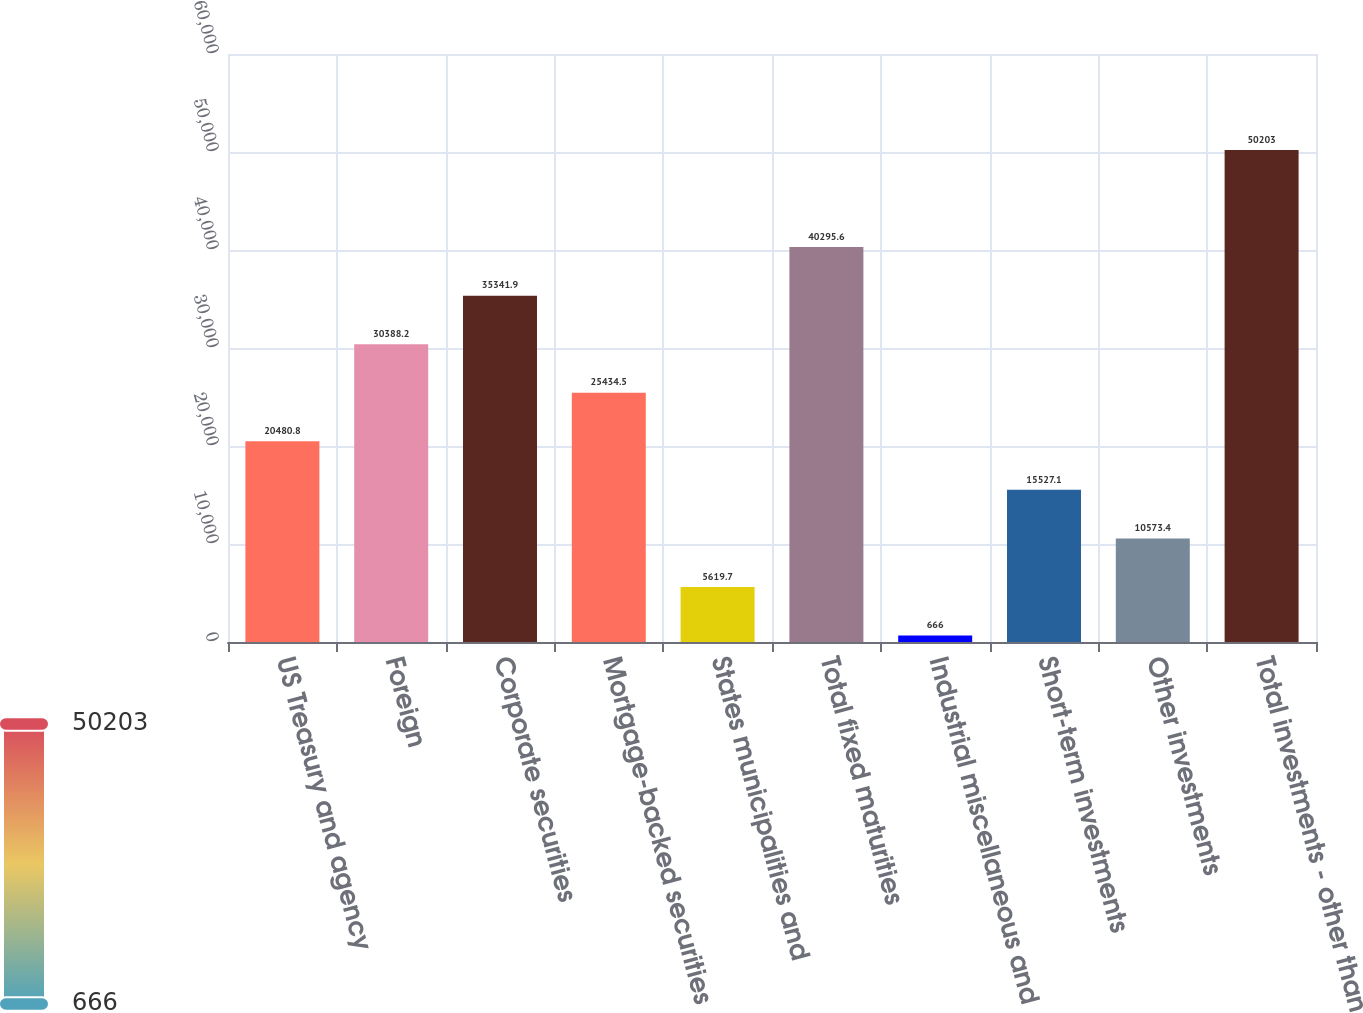Convert chart to OTSL. <chart><loc_0><loc_0><loc_500><loc_500><bar_chart><fcel>US Treasury and agency<fcel>Foreign<fcel>Corporate securities<fcel>Mortgage-backed securities<fcel>States municipalities and<fcel>Total fixed maturities<fcel>Industrial miscellaneous and<fcel>Short-term investments<fcel>Other investments<fcel>Total investments - other than<nl><fcel>20480.8<fcel>30388.2<fcel>35341.9<fcel>25434.5<fcel>5619.7<fcel>40295.6<fcel>666<fcel>15527.1<fcel>10573.4<fcel>50203<nl></chart> 